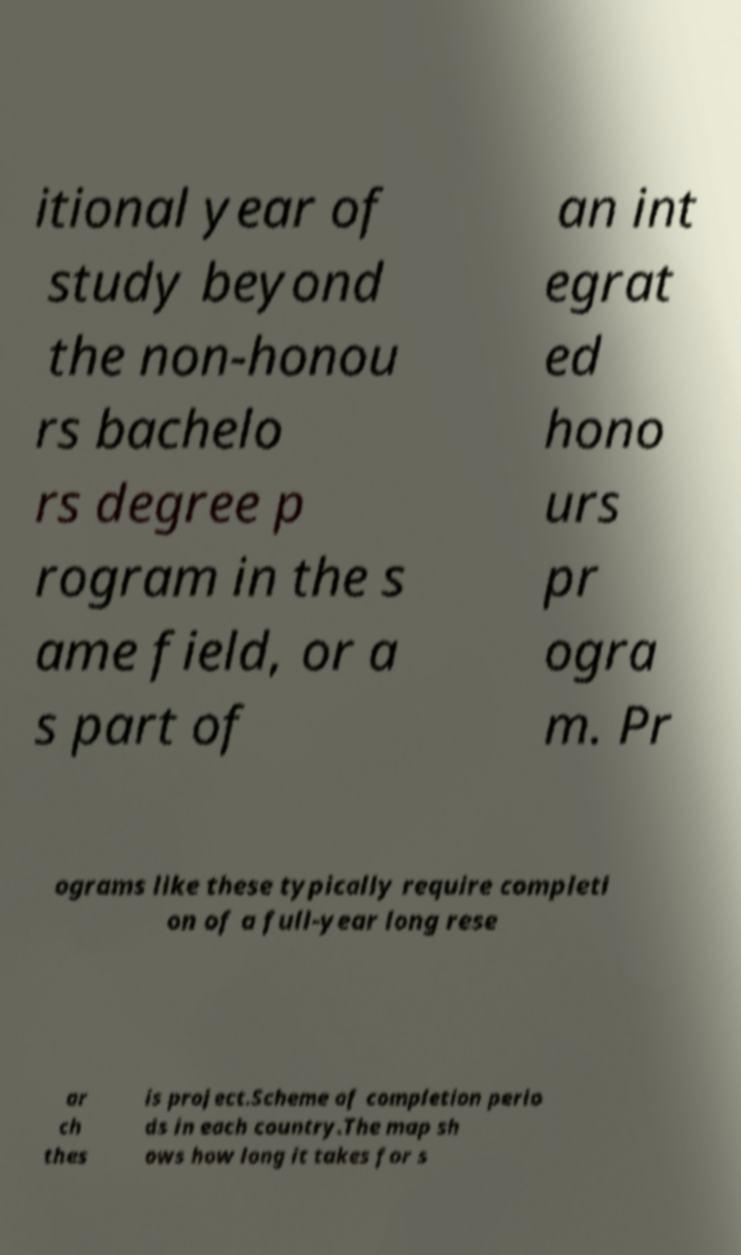I need the written content from this picture converted into text. Can you do that? itional year of study beyond the non-honou rs bachelo rs degree p rogram in the s ame field, or a s part of an int egrat ed hono urs pr ogra m. Pr ograms like these typically require completi on of a full-year long rese ar ch thes is project.Scheme of completion perio ds in each country.The map sh ows how long it takes for s 